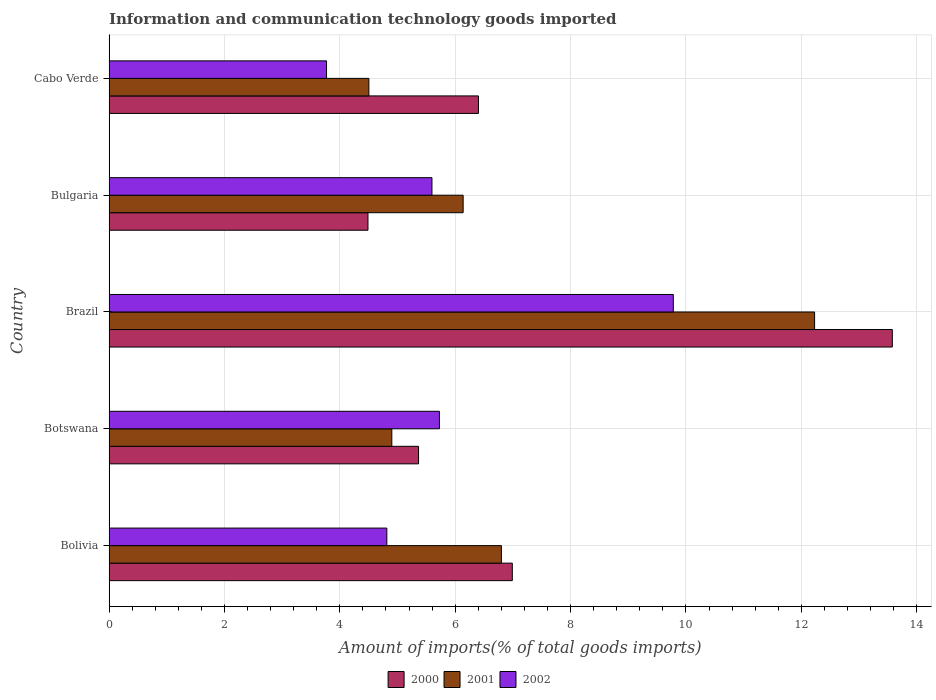Are the number of bars per tick equal to the number of legend labels?
Provide a short and direct response. Yes. How many bars are there on the 1st tick from the bottom?
Give a very brief answer. 3. What is the label of the 2nd group of bars from the top?
Make the answer very short. Bulgaria. In how many cases, is the number of bars for a given country not equal to the number of legend labels?
Ensure brevity in your answer.  0. What is the amount of goods imported in 2001 in Botswana?
Your response must be concise. 4.9. Across all countries, what is the maximum amount of goods imported in 2000?
Provide a short and direct response. 13.58. Across all countries, what is the minimum amount of goods imported in 2002?
Offer a terse response. 3.77. In which country was the amount of goods imported in 2000 maximum?
Provide a short and direct response. Brazil. In which country was the amount of goods imported in 2002 minimum?
Offer a very short reply. Cabo Verde. What is the total amount of goods imported in 2001 in the graph?
Your answer should be very brief. 34.57. What is the difference between the amount of goods imported in 2001 in Bolivia and that in Bulgaria?
Keep it short and to the point. 0.66. What is the difference between the amount of goods imported in 2001 in Bolivia and the amount of goods imported in 2000 in Brazil?
Your answer should be compact. -6.78. What is the average amount of goods imported in 2000 per country?
Keep it short and to the point. 7.37. What is the difference between the amount of goods imported in 2001 and amount of goods imported in 2002 in Brazil?
Provide a short and direct response. 2.45. In how many countries, is the amount of goods imported in 2001 greater than 2.8 %?
Provide a succinct answer. 5. What is the ratio of the amount of goods imported in 2000 in Brazil to that in Bulgaria?
Provide a short and direct response. 3.03. What is the difference between the highest and the second highest amount of goods imported in 2002?
Your answer should be very brief. 4.05. What is the difference between the highest and the lowest amount of goods imported in 2000?
Your answer should be very brief. 9.09. Is the sum of the amount of goods imported in 2001 in Bolivia and Bulgaria greater than the maximum amount of goods imported in 2000 across all countries?
Ensure brevity in your answer.  No. What does the 2nd bar from the top in Botswana represents?
Give a very brief answer. 2001. Is it the case that in every country, the sum of the amount of goods imported in 2001 and amount of goods imported in 2002 is greater than the amount of goods imported in 2000?
Give a very brief answer. Yes. How many bars are there?
Make the answer very short. 15. How many countries are there in the graph?
Provide a succinct answer. 5. How many legend labels are there?
Your response must be concise. 3. What is the title of the graph?
Make the answer very short. Information and communication technology goods imported. What is the label or title of the X-axis?
Offer a terse response. Amount of imports(% of total goods imports). What is the label or title of the Y-axis?
Offer a very short reply. Country. What is the Amount of imports(% of total goods imports) of 2000 in Bolivia?
Offer a terse response. 6.99. What is the Amount of imports(% of total goods imports) of 2001 in Bolivia?
Make the answer very short. 6.8. What is the Amount of imports(% of total goods imports) in 2002 in Bolivia?
Your answer should be very brief. 4.82. What is the Amount of imports(% of total goods imports) of 2000 in Botswana?
Your answer should be compact. 5.37. What is the Amount of imports(% of total goods imports) in 2001 in Botswana?
Provide a short and direct response. 4.9. What is the Amount of imports(% of total goods imports) in 2002 in Botswana?
Your answer should be very brief. 5.73. What is the Amount of imports(% of total goods imports) of 2000 in Brazil?
Keep it short and to the point. 13.58. What is the Amount of imports(% of total goods imports) of 2001 in Brazil?
Provide a short and direct response. 12.23. What is the Amount of imports(% of total goods imports) of 2002 in Brazil?
Offer a very short reply. 9.78. What is the Amount of imports(% of total goods imports) in 2000 in Bulgaria?
Give a very brief answer. 4.49. What is the Amount of imports(% of total goods imports) in 2001 in Bulgaria?
Offer a very short reply. 6.14. What is the Amount of imports(% of total goods imports) in 2002 in Bulgaria?
Your response must be concise. 5.6. What is the Amount of imports(% of total goods imports) of 2000 in Cabo Verde?
Offer a terse response. 6.4. What is the Amount of imports(% of total goods imports) of 2001 in Cabo Verde?
Offer a terse response. 4.5. What is the Amount of imports(% of total goods imports) of 2002 in Cabo Verde?
Your answer should be compact. 3.77. Across all countries, what is the maximum Amount of imports(% of total goods imports) in 2000?
Keep it short and to the point. 13.58. Across all countries, what is the maximum Amount of imports(% of total goods imports) of 2001?
Offer a very short reply. 12.23. Across all countries, what is the maximum Amount of imports(% of total goods imports) of 2002?
Make the answer very short. 9.78. Across all countries, what is the minimum Amount of imports(% of total goods imports) in 2000?
Your response must be concise. 4.49. Across all countries, what is the minimum Amount of imports(% of total goods imports) of 2001?
Your answer should be compact. 4.5. Across all countries, what is the minimum Amount of imports(% of total goods imports) of 2002?
Ensure brevity in your answer.  3.77. What is the total Amount of imports(% of total goods imports) in 2000 in the graph?
Give a very brief answer. 36.83. What is the total Amount of imports(% of total goods imports) in 2001 in the graph?
Your answer should be compact. 34.58. What is the total Amount of imports(% of total goods imports) of 2002 in the graph?
Your answer should be very brief. 29.69. What is the difference between the Amount of imports(% of total goods imports) of 2000 in Bolivia and that in Botswana?
Your response must be concise. 1.63. What is the difference between the Amount of imports(% of total goods imports) of 2001 in Bolivia and that in Botswana?
Provide a succinct answer. 1.9. What is the difference between the Amount of imports(% of total goods imports) of 2002 in Bolivia and that in Botswana?
Offer a very short reply. -0.91. What is the difference between the Amount of imports(% of total goods imports) of 2000 in Bolivia and that in Brazil?
Your response must be concise. -6.59. What is the difference between the Amount of imports(% of total goods imports) of 2001 in Bolivia and that in Brazil?
Your answer should be compact. -5.43. What is the difference between the Amount of imports(% of total goods imports) of 2002 in Bolivia and that in Brazil?
Your answer should be compact. -4.97. What is the difference between the Amount of imports(% of total goods imports) in 2000 in Bolivia and that in Bulgaria?
Provide a short and direct response. 2.5. What is the difference between the Amount of imports(% of total goods imports) of 2001 in Bolivia and that in Bulgaria?
Your answer should be compact. 0.66. What is the difference between the Amount of imports(% of total goods imports) of 2002 in Bolivia and that in Bulgaria?
Your response must be concise. -0.78. What is the difference between the Amount of imports(% of total goods imports) in 2000 in Bolivia and that in Cabo Verde?
Your answer should be compact. 0.59. What is the difference between the Amount of imports(% of total goods imports) of 2001 in Bolivia and that in Cabo Verde?
Give a very brief answer. 2.3. What is the difference between the Amount of imports(% of total goods imports) in 2002 in Bolivia and that in Cabo Verde?
Your answer should be compact. 1.05. What is the difference between the Amount of imports(% of total goods imports) in 2000 in Botswana and that in Brazil?
Provide a succinct answer. -8.21. What is the difference between the Amount of imports(% of total goods imports) in 2001 in Botswana and that in Brazil?
Provide a succinct answer. -7.33. What is the difference between the Amount of imports(% of total goods imports) of 2002 in Botswana and that in Brazil?
Keep it short and to the point. -4.05. What is the difference between the Amount of imports(% of total goods imports) of 2000 in Botswana and that in Bulgaria?
Make the answer very short. 0.88. What is the difference between the Amount of imports(% of total goods imports) in 2001 in Botswana and that in Bulgaria?
Your response must be concise. -1.24. What is the difference between the Amount of imports(% of total goods imports) of 2002 in Botswana and that in Bulgaria?
Offer a very short reply. 0.13. What is the difference between the Amount of imports(% of total goods imports) of 2000 in Botswana and that in Cabo Verde?
Provide a succinct answer. -1.04. What is the difference between the Amount of imports(% of total goods imports) in 2001 in Botswana and that in Cabo Verde?
Provide a short and direct response. 0.4. What is the difference between the Amount of imports(% of total goods imports) of 2002 in Botswana and that in Cabo Verde?
Offer a very short reply. 1.96. What is the difference between the Amount of imports(% of total goods imports) of 2000 in Brazil and that in Bulgaria?
Make the answer very short. 9.09. What is the difference between the Amount of imports(% of total goods imports) of 2001 in Brazil and that in Bulgaria?
Ensure brevity in your answer.  6.09. What is the difference between the Amount of imports(% of total goods imports) in 2002 in Brazil and that in Bulgaria?
Provide a short and direct response. 4.18. What is the difference between the Amount of imports(% of total goods imports) in 2000 in Brazil and that in Cabo Verde?
Give a very brief answer. 7.17. What is the difference between the Amount of imports(% of total goods imports) in 2001 in Brazil and that in Cabo Verde?
Offer a terse response. 7.73. What is the difference between the Amount of imports(% of total goods imports) in 2002 in Brazil and that in Cabo Verde?
Ensure brevity in your answer.  6.01. What is the difference between the Amount of imports(% of total goods imports) in 2000 in Bulgaria and that in Cabo Verde?
Ensure brevity in your answer.  -1.92. What is the difference between the Amount of imports(% of total goods imports) of 2001 in Bulgaria and that in Cabo Verde?
Give a very brief answer. 1.63. What is the difference between the Amount of imports(% of total goods imports) of 2002 in Bulgaria and that in Cabo Verde?
Your answer should be very brief. 1.83. What is the difference between the Amount of imports(% of total goods imports) in 2000 in Bolivia and the Amount of imports(% of total goods imports) in 2001 in Botswana?
Ensure brevity in your answer.  2.09. What is the difference between the Amount of imports(% of total goods imports) in 2000 in Bolivia and the Amount of imports(% of total goods imports) in 2002 in Botswana?
Your response must be concise. 1.26. What is the difference between the Amount of imports(% of total goods imports) of 2001 in Bolivia and the Amount of imports(% of total goods imports) of 2002 in Botswana?
Ensure brevity in your answer.  1.07. What is the difference between the Amount of imports(% of total goods imports) of 2000 in Bolivia and the Amount of imports(% of total goods imports) of 2001 in Brazil?
Offer a terse response. -5.24. What is the difference between the Amount of imports(% of total goods imports) in 2000 in Bolivia and the Amount of imports(% of total goods imports) in 2002 in Brazil?
Provide a succinct answer. -2.79. What is the difference between the Amount of imports(% of total goods imports) in 2001 in Bolivia and the Amount of imports(% of total goods imports) in 2002 in Brazil?
Offer a very short reply. -2.98. What is the difference between the Amount of imports(% of total goods imports) of 2000 in Bolivia and the Amount of imports(% of total goods imports) of 2001 in Bulgaria?
Your answer should be very brief. 0.85. What is the difference between the Amount of imports(% of total goods imports) in 2000 in Bolivia and the Amount of imports(% of total goods imports) in 2002 in Bulgaria?
Make the answer very short. 1.39. What is the difference between the Amount of imports(% of total goods imports) of 2001 in Bolivia and the Amount of imports(% of total goods imports) of 2002 in Bulgaria?
Your response must be concise. 1.2. What is the difference between the Amount of imports(% of total goods imports) in 2000 in Bolivia and the Amount of imports(% of total goods imports) in 2001 in Cabo Verde?
Provide a short and direct response. 2.49. What is the difference between the Amount of imports(% of total goods imports) in 2000 in Bolivia and the Amount of imports(% of total goods imports) in 2002 in Cabo Verde?
Offer a very short reply. 3.22. What is the difference between the Amount of imports(% of total goods imports) of 2001 in Bolivia and the Amount of imports(% of total goods imports) of 2002 in Cabo Verde?
Make the answer very short. 3.03. What is the difference between the Amount of imports(% of total goods imports) of 2000 in Botswana and the Amount of imports(% of total goods imports) of 2001 in Brazil?
Keep it short and to the point. -6.87. What is the difference between the Amount of imports(% of total goods imports) of 2000 in Botswana and the Amount of imports(% of total goods imports) of 2002 in Brazil?
Your answer should be compact. -4.42. What is the difference between the Amount of imports(% of total goods imports) of 2001 in Botswana and the Amount of imports(% of total goods imports) of 2002 in Brazil?
Your response must be concise. -4.88. What is the difference between the Amount of imports(% of total goods imports) of 2000 in Botswana and the Amount of imports(% of total goods imports) of 2001 in Bulgaria?
Ensure brevity in your answer.  -0.77. What is the difference between the Amount of imports(% of total goods imports) in 2000 in Botswana and the Amount of imports(% of total goods imports) in 2002 in Bulgaria?
Provide a succinct answer. -0.23. What is the difference between the Amount of imports(% of total goods imports) of 2001 in Botswana and the Amount of imports(% of total goods imports) of 2002 in Bulgaria?
Make the answer very short. -0.7. What is the difference between the Amount of imports(% of total goods imports) of 2000 in Botswana and the Amount of imports(% of total goods imports) of 2001 in Cabo Verde?
Make the answer very short. 0.86. What is the difference between the Amount of imports(% of total goods imports) of 2000 in Botswana and the Amount of imports(% of total goods imports) of 2002 in Cabo Verde?
Give a very brief answer. 1.6. What is the difference between the Amount of imports(% of total goods imports) in 2001 in Botswana and the Amount of imports(% of total goods imports) in 2002 in Cabo Verde?
Your answer should be very brief. 1.13. What is the difference between the Amount of imports(% of total goods imports) in 2000 in Brazil and the Amount of imports(% of total goods imports) in 2001 in Bulgaria?
Make the answer very short. 7.44. What is the difference between the Amount of imports(% of total goods imports) in 2000 in Brazil and the Amount of imports(% of total goods imports) in 2002 in Bulgaria?
Give a very brief answer. 7.98. What is the difference between the Amount of imports(% of total goods imports) in 2001 in Brazil and the Amount of imports(% of total goods imports) in 2002 in Bulgaria?
Provide a succinct answer. 6.63. What is the difference between the Amount of imports(% of total goods imports) of 2000 in Brazil and the Amount of imports(% of total goods imports) of 2001 in Cabo Verde?
Keep it short and to the point. 9.07. What is the difference between the Amount of imports(% of total goods imports) of 2000 in Brazil and the Amount of imports(% of total goods imports) of 2002 in Cabo Verde?
Provide a short and direct response. 9.81. What is the difference between the Amount of imports(% of total goods imports) in 2001 in Brazil and the Amount of imports(% of total goods imports) in 2002 in Cabo Verde?
Your answer should be very brief. 8.46. What is the difference between the Amount of imports(% of total goods imports) in 2000 in Bulgaria and the Amount of imports(% of total goods imports) in 2001 in Cabo Verde?
Your response must be concise. -0.02. What is the difference between the Amount of imports(% of total goods imports) of 2000 in Bulgaria and the Amount of imports(% of total goods imports) of 2002 in Cabo Verde?
Offer a terse response. 0.72. What is the difference between the Amount of imports(% of total goods imports) in 2001 in Bulgaria and the Amount of imports(% of total goods imports) in 2002 in Cabo Verde?
Give a very brief answer. 2.37. What is the average Amount of imports(% of total goods imports) in 2000 per country?
Your response must be concise. 7.37. What is the average Amount of imports(% of total goods imports) in 2001 per country?
Offer a terse response. 6.92. What is the average Amount of imports(% of total goods imports) in 2002 per country?
Offer a very short reply. 5.94. What is the difference between the Amount of imports(% of total goods imports) of 2000 and Amount of imports(% of total goods imports) of 2001 in Bolivia?
Offer a terse response. 0.19. What is the difference between the Amount of imports(% of total goods imports) of 2000 and Amount of imports(% of total goods imports) of 2002 in Bolivia?
Offer a terse response. 2.17. What is the difference between the Amount of imports(% of total goods imports) in 2001 and Amount of imports(% of total goods imports) in 2002 in Bolivia?
Provide a short and direct response. 1.99. What is the difference between the Amount of imports(% of total goods imports) in 2000 and Amount of imports(% of total goods imports) in 2001 in Botswana?
Provide a short and direct response. 0.46. What is the difference between the Amount of imports(% of total goods imports) of 2000 and Amount of imports(% of total goods imports) of 2002 in Botswana?
Offer a terse response. -0.36. What is the difference between the Amount of imports(% of total goods imports) of 2001 and Amount of imports(% of total goods imports) of 2002 in Botswana?
Offer a very short reply. -0.83. What is the difference between the Amount of imports(% of total goods imports) of 2000 and Amount of imports(% of total goods imports) of 2001 in Brazil?
Provide a short and direct response. 1.35. What is the difference between the Amount of imports(% of total goods imports) of 2000 and Amount of imports(% of total goods imports) of 2002 in Brazil?
Keep it short and to the point. 3.8. What is the difference between the Amount of imports(% of total goods imports) in 2001 and Amount of imports(% of total goods imports) in 2002 in Brazil?
Provide a short and direct response. 2.45. What is the difference between the Amount of imports(% of total goods imports) in 2000 and Amount of imports(% of total goods imports) in 2001 in Bulgaria?
Your answer should be compact. -1.65. What is the difference between the Amount of imports(% of total goods imports) in 2000 and Amount of imports(% of total goods imports) in 2002 in Bulgaria?
Your answer should be compact. -1.11. What is the difference between the Amount of imports(% of total goods imports) in 2001 and Amount of imports(% of total goods imports) in 2002 in Bulgaria?
Your answer should be compact. 0.54. What is the difference between the Amount of imports(% of total goods imports) in 2000 and Amount of imports(% of total goods imports) in 2001 in Cabo Verde?
Your answer should be very brief. 1.9. What is the difference between the Amount of imports(% of total goods imports) of 2000 and Amount of imports(% of total goods imports) of 2002 in Cabo Verde?
Keep it short and to the point. 2.63. What is the difference between the Amount of imports(% of total goods imports) of 2001 and Amount of imports(% of total goods imports) of 2002 in Cabo Verde?
Offer a terse response. 0.73. What is the ratio of the Amount of imports(% of total goods imports) in 2000 in Bolivia to that in Botswana?
Ensure brevity in your answer.  1.3. What is the ratio of the Amount of imports(% of total goods imports) of 2001 in Bolivia to that in Botswana?
Offer a very short reply. 1.39. What is the ratio of the Amount of imports(% of total goods imports) in 2002 in Bolivia to that in Botswana?
Keep it short and to the point. 0.84. What is the ratio of the Amount of imports(% of total goods imports) of 2000 in Bolivia to that in Brazil?
Offer a very short reply. 0.51. What is the ratio of the Amount of imports(% of total goods imports) of 2001 in Bolivia to that in Brazil?
Offer a terse response. 0.56. What is the ratio of the Amount of imports(% of total goods imports) of 2002 in Bolivia to that in Brazil?
Keep it short and to the point. 0.49. What is the ratio of the Amount of imports(% of total goods imports) of 2000 in Bolivia to that in Bulgaria?
Offer a very short reply. 1.56. What is the ratio of the Amount of imports(% of total goods imports) in 2001 in Bolivia to that in Bulgaria?
Your answer should be compact. 1.11. What is the ratio of the Amount of imports(% of total goods imports) of 2002 in Bolivia to that in Bulgaria?
Provide a succinct answer. 0.86. What is the ratio of the Amount of imports(% of total goods imports) of 2000 in Bolivia to that in Cabo Verde?
Offer a terse response. 1.09. What is the ratio of the Amount of imports(% of total goods imports) of 2001 in Bolivia to that in Cabo Verde?
Make the answer very short. 1.51. What is the ratio of the Amount of imports(% of total goods imports) of 2002 in Bolivia to that in Cabo Verde?
Your answer should be compact. 1.28. What is the ratio of the Amount of imports(% of total goods imports) in 2000 in Botswana to that in Brazil?
Give a very brief answer. 0.4. What is the ratio of the Amount of imports(% of total goods imports) in 2001 in Botswana to that in Brazil?
Make the answer very short. 0.4. What is the ratio of the Amount of imports(% of total goods imports) in 2002 in Botswana to that in Brazil?
Your answer should be very brief. 0.59. What is the ratio of the Amount of imports(% of total goods imports) in 2000 in Botswana to that in Bulgaria?
Your answer should be compact. 1.2. What is the ratio of the Amount of imports(% of total goods imports) of 2001 in Botswana to that in Bulgaria?
Provide a succinct answer. 0.8. What is the ratio of the Amount of imports(% of total goods imports) of 2002 in Botswana to that in Bulgaria?
Provide a short and direct response. 1.02. What is the ratio of the Amount of imports(% of total goods imports) in 2000 in Botswana to that in Cabo Verde?
Your response must be concise. 0.84. What is the ratio of the Amount of imports(% of total goods imports) in 2001 in Botswana to that in Cabo Verde?
Your response must be concise. 1.09. What is the ratio of the Amount of imports(% of total goods imports) in 2002 in Botswana to that in Cabo Verde?
Your response must be concise. 1.52. What is the ratio of the Amount of imports(% of total goods imports) of 2000 in Brazil to that in Bulgaria?
Ensure brevity in your answer.  3.03. What is the ratio of the Amount of imports(% of total goods imports) of 2001 in Brazil to that in Bulgaria?
Your answer should be very brief. 1.99. What is the ratio of the Amount of imports(% of total goods imports) of 2002 in Brazil to that in Bulgaria?
Your answer should be compact. 1.75. What is the ratio of the Amount of imports(% of total goods imports) of 2000 in Brazil to that in Cabo Verde?
Provide a succinct answer. 2.12. What is the ratio of the Amount of imports(% of total goods imports) of 2001 in Brazil to that in Cabo Verde?
Your answer should be very brief. 2.72. What is the ratio of the Amount of imports(% of total goods imports) in 2002 in Brazil to that in Cabo Verde?
Offer a terse response. 2.59. What is the ratio of the Amount of imports(% of total goods imports) in 2000 in Bulgaria to that in Cabo Verde?
Your answer should be very brief. 0.7. What is the ratio of the Amount of imports(% of total goods imports) of 2001 in Bulgaria to that in Cabo Verde?
Your answer should be compact. 1.36. What is the ratio of the Amount of imports(% of total goods imports) in 2002 in Bulgaria to that in Cabo Verde?
Ensure brevity in your answer.  1.48. What is the difference between the highest and the second highest Amount of imports(% of total goods imports) of 2000?
Your response must be concise. 6.59. What is the difference between the highest and the second highest Amount of imports(% of total goods imports) of 2001?
Offer a very short reply. 5.43. What is the difference between the highest and the second highest Amount of imports(% of total goods imports) of 2002?
Make the answer very short. 4.05. What is the difference between the highest and the lowest Amount of imports(% of total goods imports) in 2000?
Your answer should be compact. 9.09. What is the difference between the highest and the lowest Amount of imports(% of total goods imports) in 2001?
Make the answer very short. 7.73. What is the difference between the highest and the lowest Amount of imports(% of total goods imports) of 2002?
Make the answer very short. 6.01. 